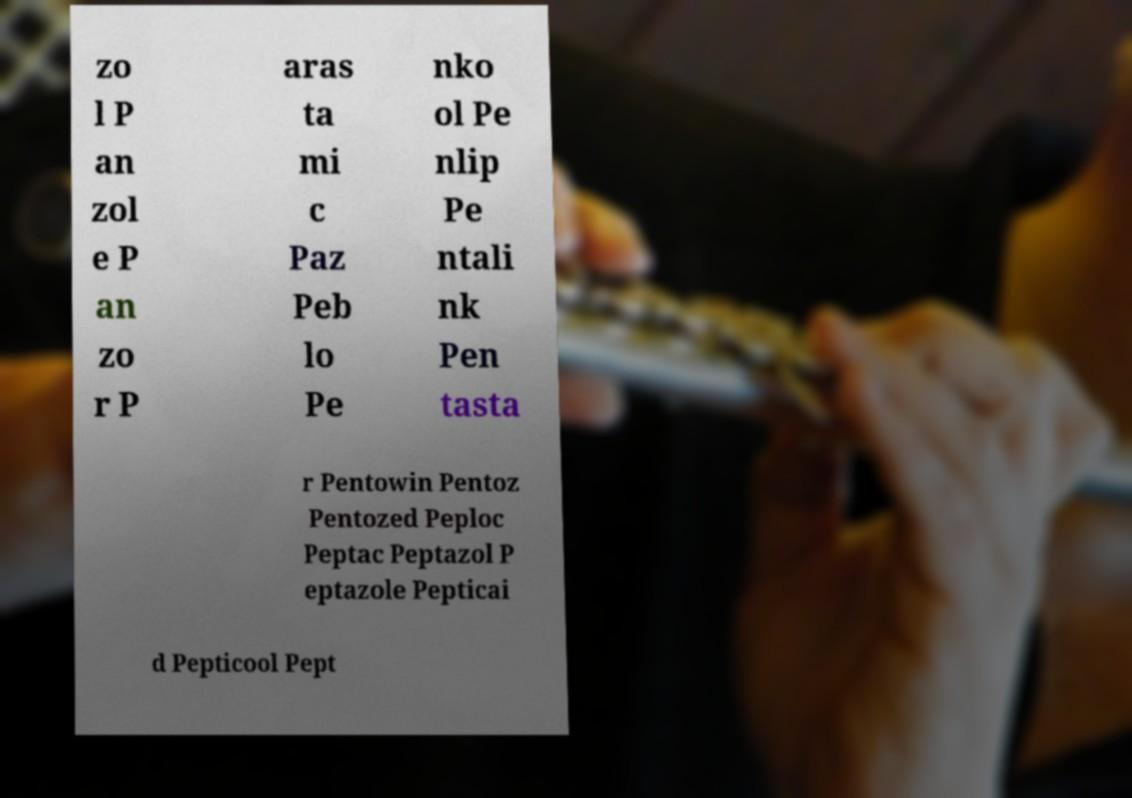Please read and relay the text visible in this image. What does it say? zo l P an zol e P an zo r P aras ta mi c Paz Peb lo Pe nko ol Pe nlip Pe ntali nk Pen tasta r Pentowin Pentoz Pentozed Peploc Peptac Peptazol P eptazole Pepticai d Pepticool Pept 